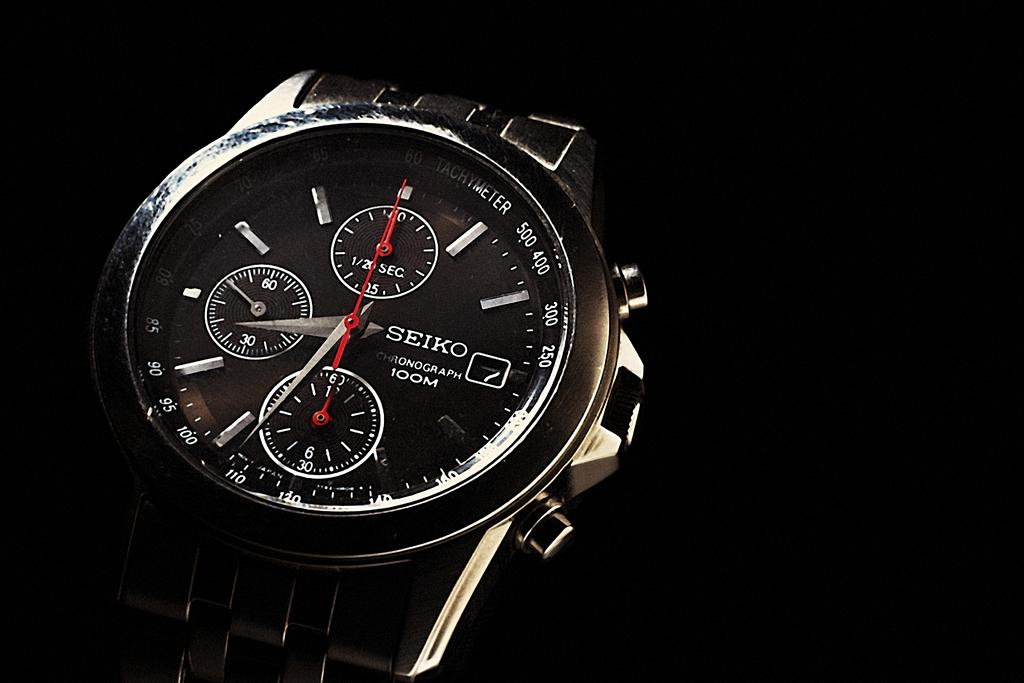<image>
Describe the image concisely. A seiko watch has a black face and background. 